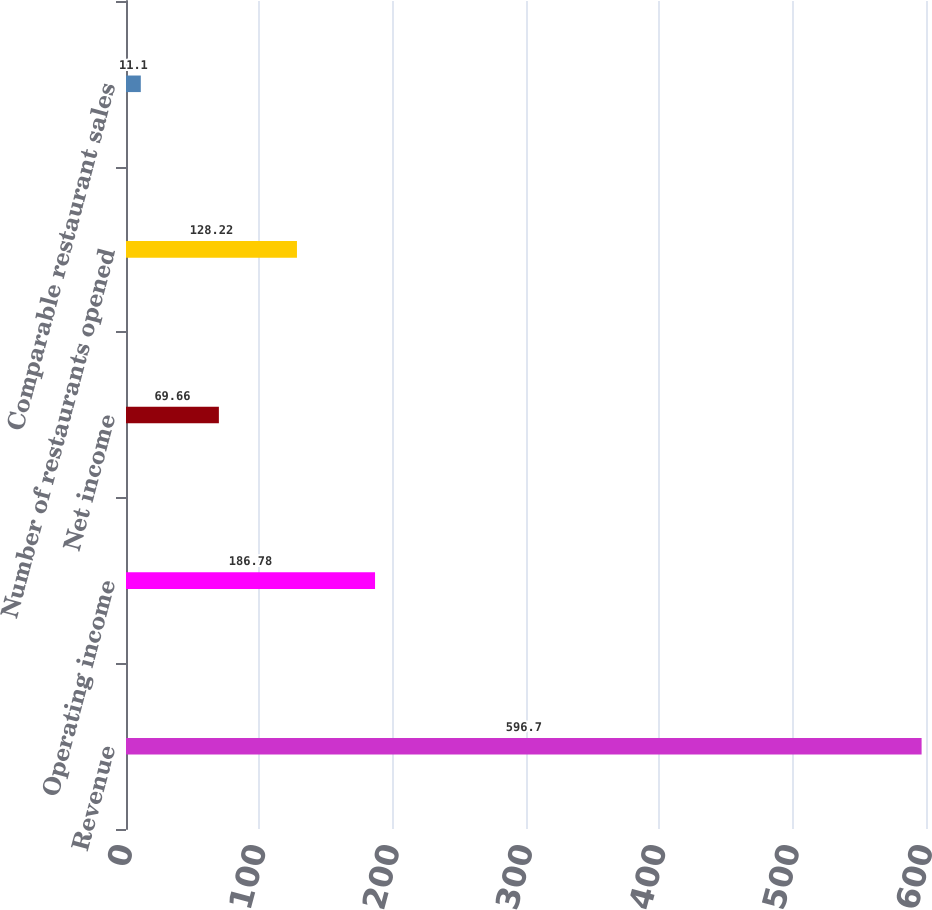Convert chart to OTSL. <chart><loc_0><loc_0><loc_500><loc_500><bar_chart><fcel>Revenue<fcel>Operating income<fcel>Net income<fcel>Number of restaurants opened<fcel>Comparable restaurant sales<nl><fcel>596.7<fcel>186.78<fcel>69.66<fcel>128.22<fcel>11.1<nl></chart> 